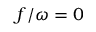Convert formula to latex. <formula><loc_0><loc_0><loc_500><loc_500>f / \omega = 0</formula> 